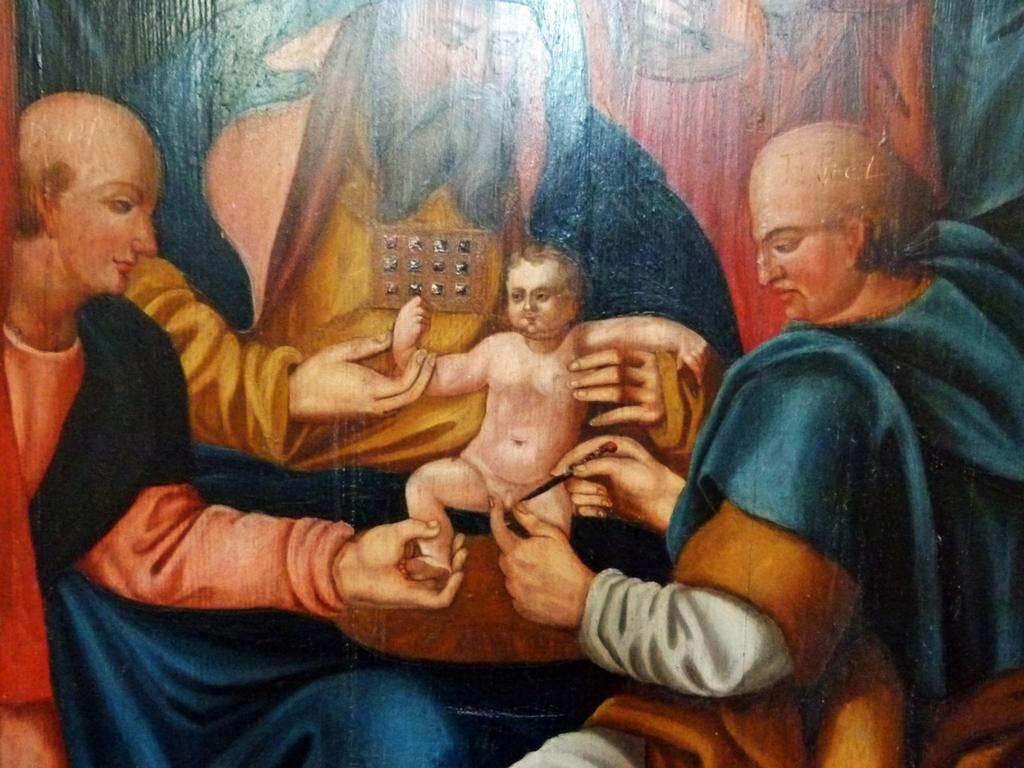How would you summarize this image in a sentence or two? In this picture we can see painting of some persons and there is a kid. 